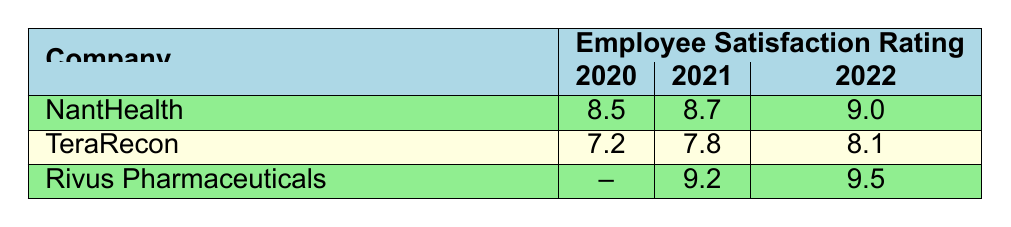What was the satisfaction rating at NantHealth in 2021? According to the table, the satisfaction rating for NantHealth in 2021 is directly listed as 8.7.
Answer: 8.7 What is the highest satisfaction rating recorded at Rivus Pharmaceuticals? The table shows satisfaction ratings for Rivus Pharmaceuticals in 2021 (9.2), 2022 (9.5), and 2023 (9.6). The highest among these is 9.6 in 2023.
Answer: 9.6 Did TeraRecon's satisfaction rating improve from 2020 to 2021? TeraRecon's ratings were 7.2 in 2020 and 7.8 in 2021. Since 7.8 is greater than 7.2, it indicates an improvement.
Answer: Yes What is the difference between the satisfaction ratings of NantHealth in 2020 and 2022? The satisfaction ratings for NantHealth in 2020 is 8.5 and in 2022 is 9.0. The difference is calculated as 9.0 - 8.5 = 0.5.
Answer: 0.5 Which company had the lowest satisfaction rating in 2020? From the table, TeraRecon had the lowest satisfaction rating in 2020 at 7.2. NantHealth had 8.5 that year, which is higher.
Answer: TeraRecon What was the average satisfaction rating for TeraRecon from 2020 to 2022? TeraRecon's ratings are 7.2 in 2020, 7.8 in 2021, and 8.1 in 2022. The average is calculated as (7.2 + 7.8 + 8.1) / 3 = 7.7.
Answer: 7.7 Is there a year where Rivus Pharmaceuticals had a satisfaction rating lower than 9.0? The ratings for Rivus Pharmaceuticals were 9.2 in 2021, 9.5 in 2022, and 9.6 in 2023. Therefore, there were no ratings lower than 9.0.
Answer: No What was the trend of employee satisfaction ratings for NantHealth over the years presented? The satisfaction ratings for NantHealth show an increase: 8.5 in 2020, 8.7 in 2021, and 9.0 in 2022. This indicates a positive trend in employee satisfaction over the years.
Answer: Increasing 